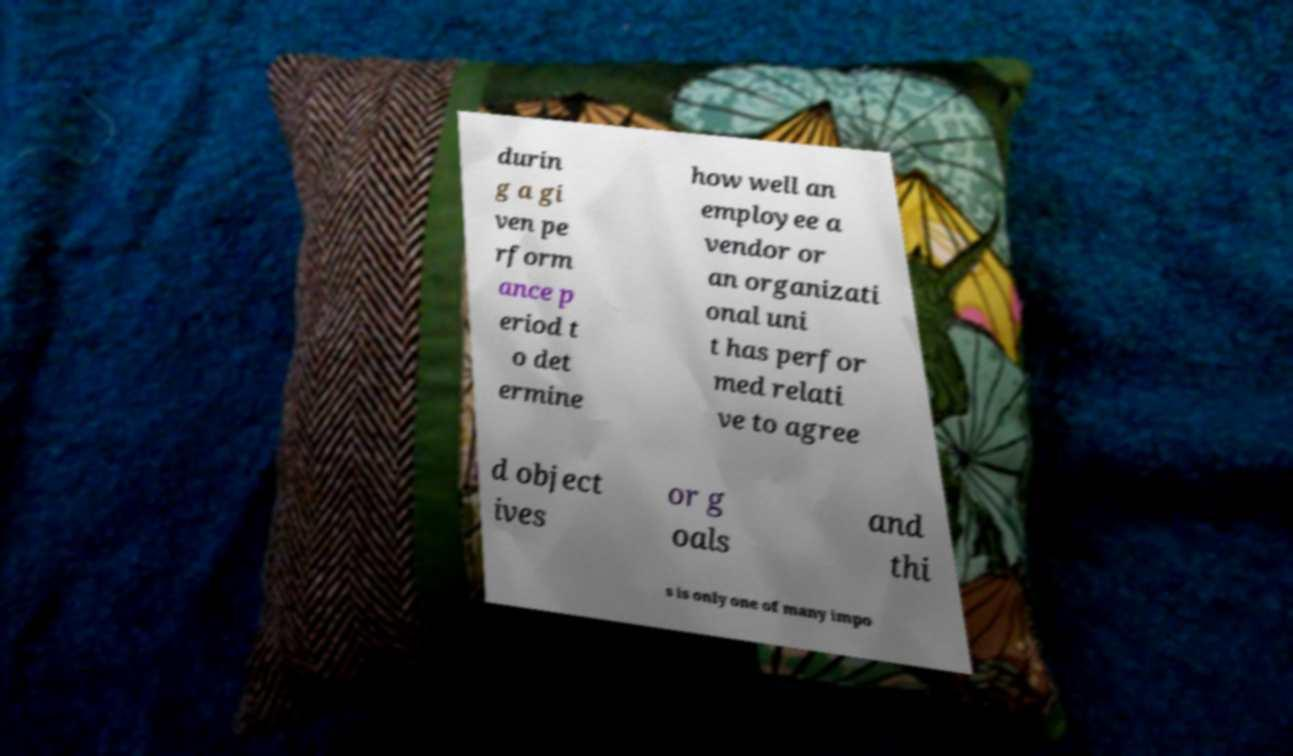What messages or text are displayed in this image? I need them in a readable, typed format. durin g a gi ven pe rform ance p eriod t o det ermine how well an employee a vendor or an organizati onal uni t has perfor med relati ve to agree d object ives or g oals and thi s is only one of many impo 